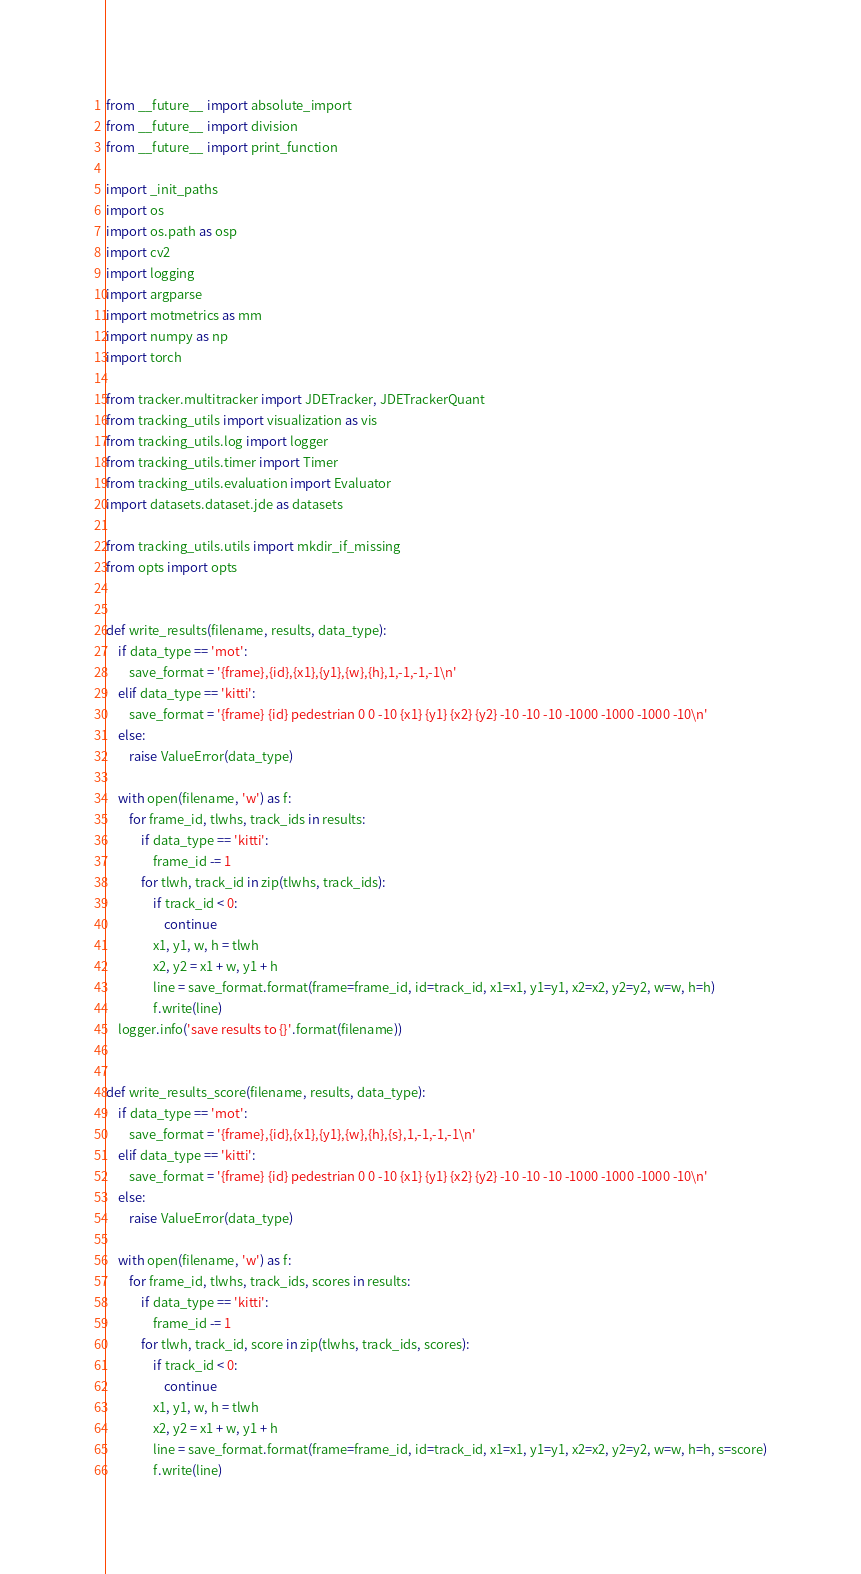<code> <loc_0><loc_0><loc_500><loc_500><_Python_>from __future__ import absolute_import
from __future__ import division
from __future__ import print_function

import _init_paths
import os
import os.path as osp
import cv2
import logging
import argparse
import motmetrics as mm
import numpy as np
import torch

from tracker.multitracker import JDETracker, JDETrackerQuant
from tracking_utils import visualization as vis
from tracking_utils.log import logger
from tracking_utils.timer import Timer
from tracking_utils.evaluation import Evaluator
import datasets.dataset.jde as datasets

from tracking_utils.utils import mkdir_if_missing
from opts import opts


def write_results(filename, results, data_type):
    if data_type == 'mot':
        save_format = '{frame},{id},{x1},{y1},{w},{h},1,-1,-1,-1\n'
    elif data_type == 'kitti':
        save_format = '{frame} {id} pedestrian 0 0 -10 {x1} {y1} {x2} {y2} -10 -10 -10 -1000 -1000 -1000 -10\n'
    else:
        raise ValueError(data_type)

    with open(filename, 'w') as f:
        for frame_id, tlwhs, track_ids in results:
            if data_type == 'kitti':
                frame_id -= 1
            for tlwh, track_id in zip(tlwhs, track_ids):
                if track_id < 0:
                    continue
                x1, y1, w, h = tlwh
                x2, y2 = x1 + w, y1 + h
                line = save_format.format(frame=frame_id, id=track_id, x1=x1, y1=y1, x2=x2, y2=y2, w=w, h=h)
                f.write(line)
    logger.info('save results to {}'.format(filename))


def write_results_score(filename, results, data_type):
    if data_type == 'mot':
        save_format = '{frame},{id},{x1},{y1},{w},{h},{s},1,-1,-1,-1\n'
    elif data_type == 'kitti':
        save_format = '{frame} {id} pedestrian 0 0 -10 {x1} {y1} {x2} {y2} -10 -10 -10 -1000 -1000 -1000 -10\n'
    else:
        raise ValueError(data_type)

    with open(filename, 'w') as f:
        for frame_id, tlwhs, track_ids, scores in results:
            if data_type == 'kitti':
                frame_id -= 1
            for tlwh, track_id, score in zip(tlwhs, track_ids, scores):
                if track_id < 0:
                    continue
                x1, y1, w, h = tlwh
                x2, y2 = x1 + w, y1 + h
                line = save_format.format(frame=frame_id, id=track_id, x1=x1, y1=y1, x2=x2, y2=y2, w=w, h=h, s=score)
                f.write(line)</code> 